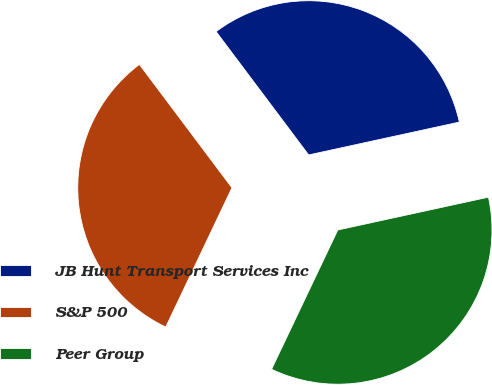Convert chart. <chart><loc_0><loc_0><loc_500><loc_500><pie_chart><fcel>JB Hunt Transport Services Inc<fcel>S&P 500<fcel>Peer Group<nl><fcel>31.83%<fcel>32.69%<fcel>35.48%<nl></chart> 